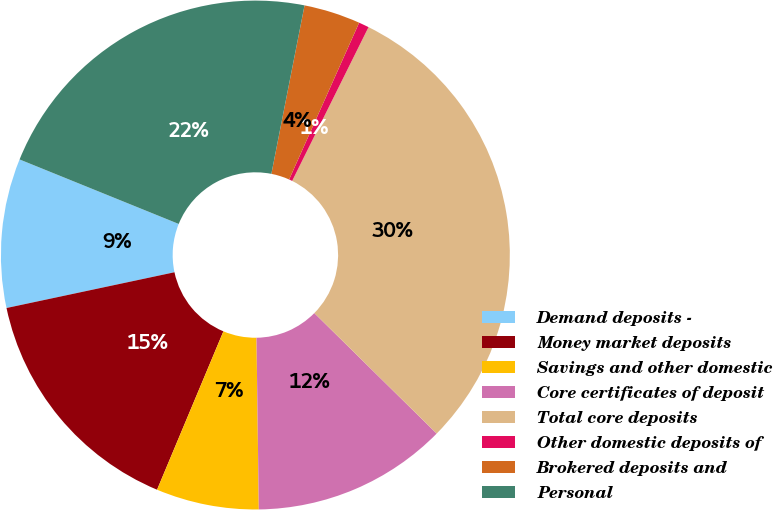Convert chart. <chart><loc_0><loc_0><loc_500><loc_500><pie_chart><fcel>Demand deposits -<fcel>Money market deposits<fcel>Savings and other domestic<fcel>Core certificates of deposit<fcel>Total core deposits<fcel>Other domestic deposits of<fcel>Brokered deposits and<fcel>Personal<nl><fcel>9.47%<fcel>15.35%<fcel>6.53%<fcel>12.41%<fcel>30.05%<fcel>0.65%<fcel>3.59%<fcel>21.97%<nl></chart> 